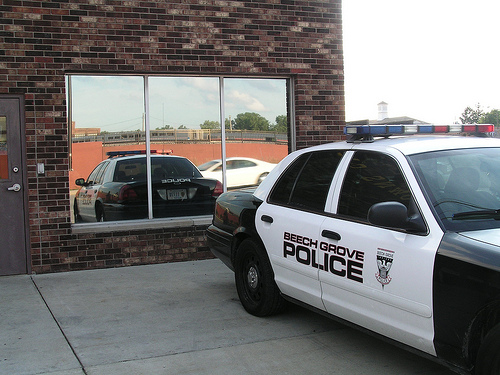<image>
Is the building behind the car? Yes. From this viewpoint, the building is positioned behind the car, with the car partially or fully occluding the building. 